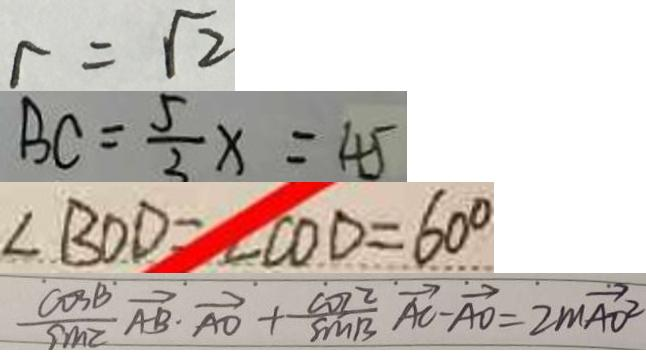<formula> <loc_0><loc_0><loc_500><loc_500>r = \sqrt { 2 } 
 B C = \frac { 5 } { 3 } x = 4 5 
 \angle B O D = \angle C O D = 6 0 ^ { \circ } 
 \frac { \cos B } { \sin C } \overrightarrow { A B } \cdot \overrightarrow { A O } + \frac { \cos 2 } { \sin B } \overrightarrow { A C } - \overrightarrow { A O } = 2 m \overrightarrow { A O ^ { 2 } }</formula> 